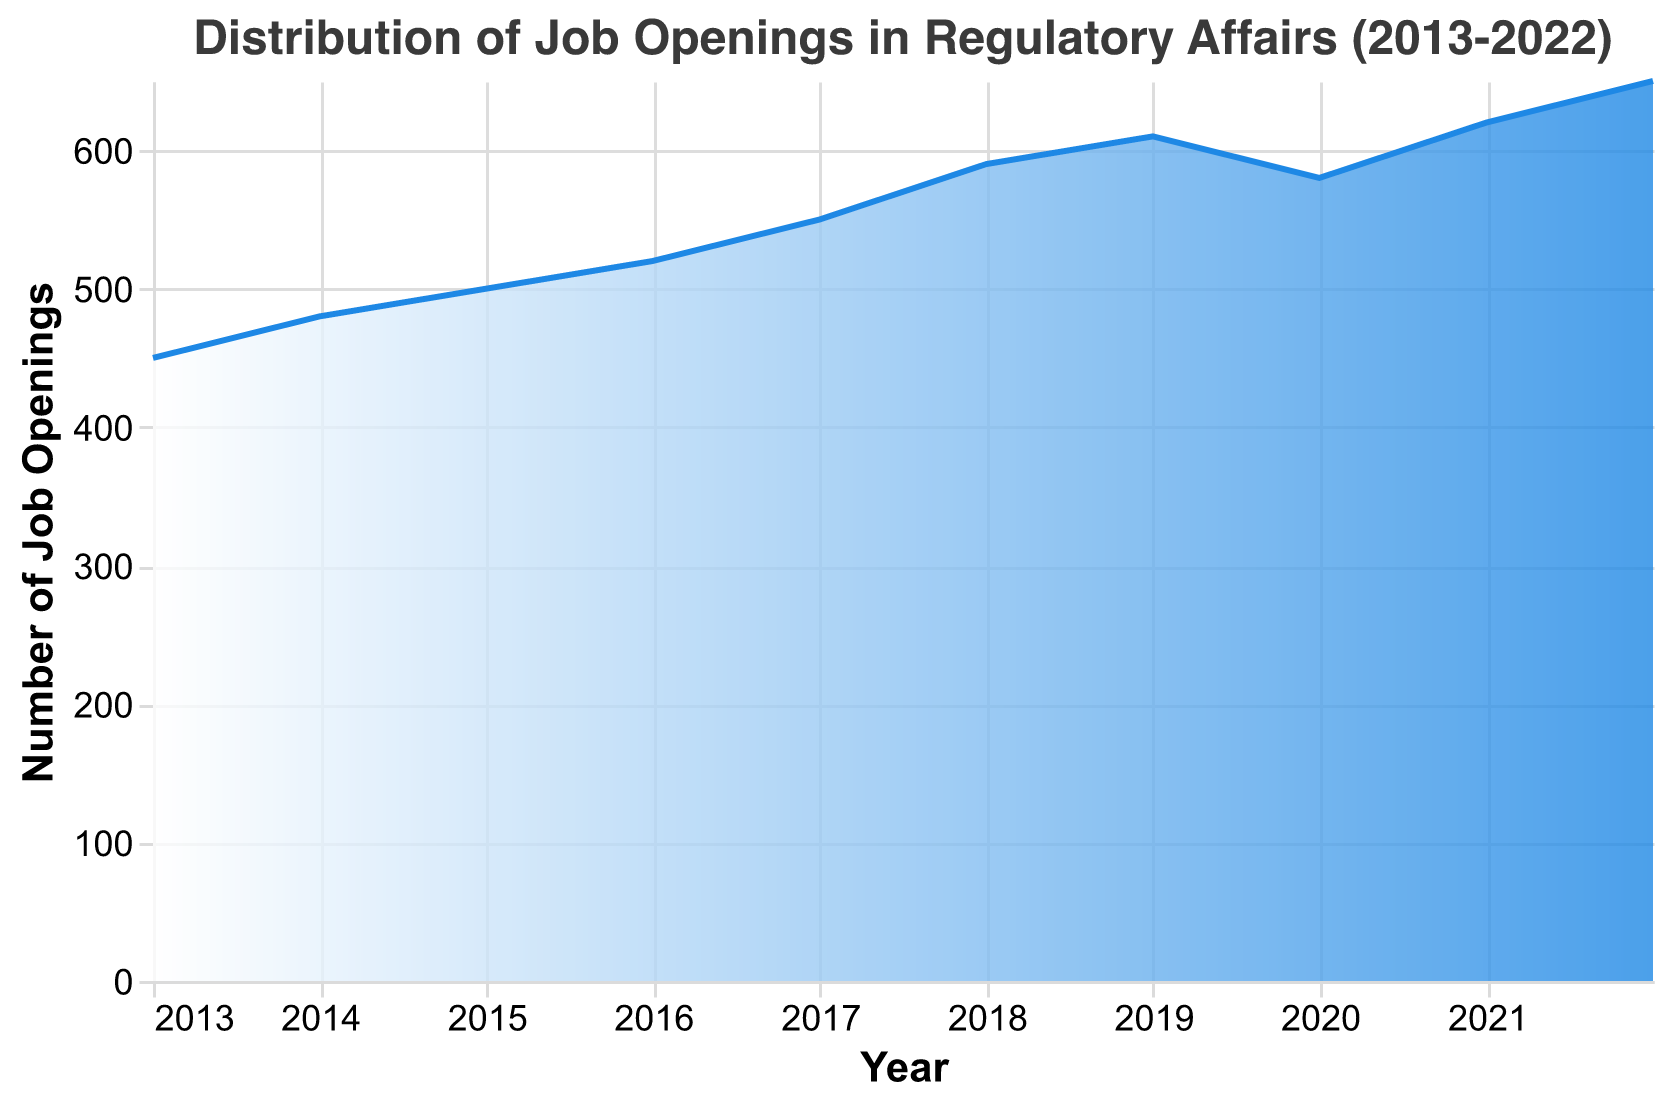How many total years of data are displayed in the figure? The plot shows data from 2013 to 2022. By counting the years from 2013 to 2022, we get a total of 10 data points.
Answer: 10 What's the general trend observed in job openings over the years? Examining the plot, job openings rise from 450 in 2013 to 650 in 2022 with a slight dip in 2020. The general direction is upward.
Answer: Increasing What year had the lowest number of job openings, and how many were there in that year? Looking at the plot, the lowest number of job openings occurred in 2013 with 450 job openings.
Answer: 2013, 450 By how much did the job openings increase from 2013 to 2022? The number of job openings in 2013 is 450 and in 2022 it is 650. The increase is 650 - 450 = 200.
Answer: 200 Which year experienced the highest number of job openings and what was the count? Referring to the plot, the highest number of job openings was in 2022 with 650 job openings.
Answer: 2022, 650 What significant event do you notice that happened in the year 2020 as shown in the figure? There is a noticeable dip in the number of job openings in 2020 compared to the previous year.
Answer: A dip in job openings What is the average number of job openings from 2013 to 2022? Summing the job openings for each year (450+480+500+520+550+590+610+580+620+650=5550) and dividing by the number of years (10) results in an average of 555.
Answer: 555 By how much did the number of job openings increase from 2019 to 2021? The openings in 2019 were 610 and in 2021 were 620. The increase is 620 - 610 = 10.
Answer: 10 Which two consecutive years had the largest increase in job openings, and what was the increase? The largest increase happened between 2017 and 2018, where openings went from 550 to 590. The increase is 590 - 550 = 40.
Answer: 2017 and 2018, 40 How much higher were job openings in 2022 compared to 2020? Job openings were 650 in 2022 and 580 in 2020. The difference is 650 - 580 = 70.
Answer: 70 